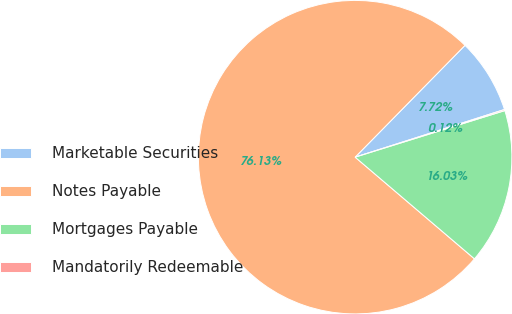<chart> <loc_0><loc_0><loc_500><loc_500><pie_chart><fcel>Marketable Securities<fcel>Notes Payable<fcel>Mortgages Payable<fcel>Mandatorily Redeemable<nl><fcel>7.72%<fcel>76.12%<fcel>16.03%<fcel>0.12%<nl></chart> 